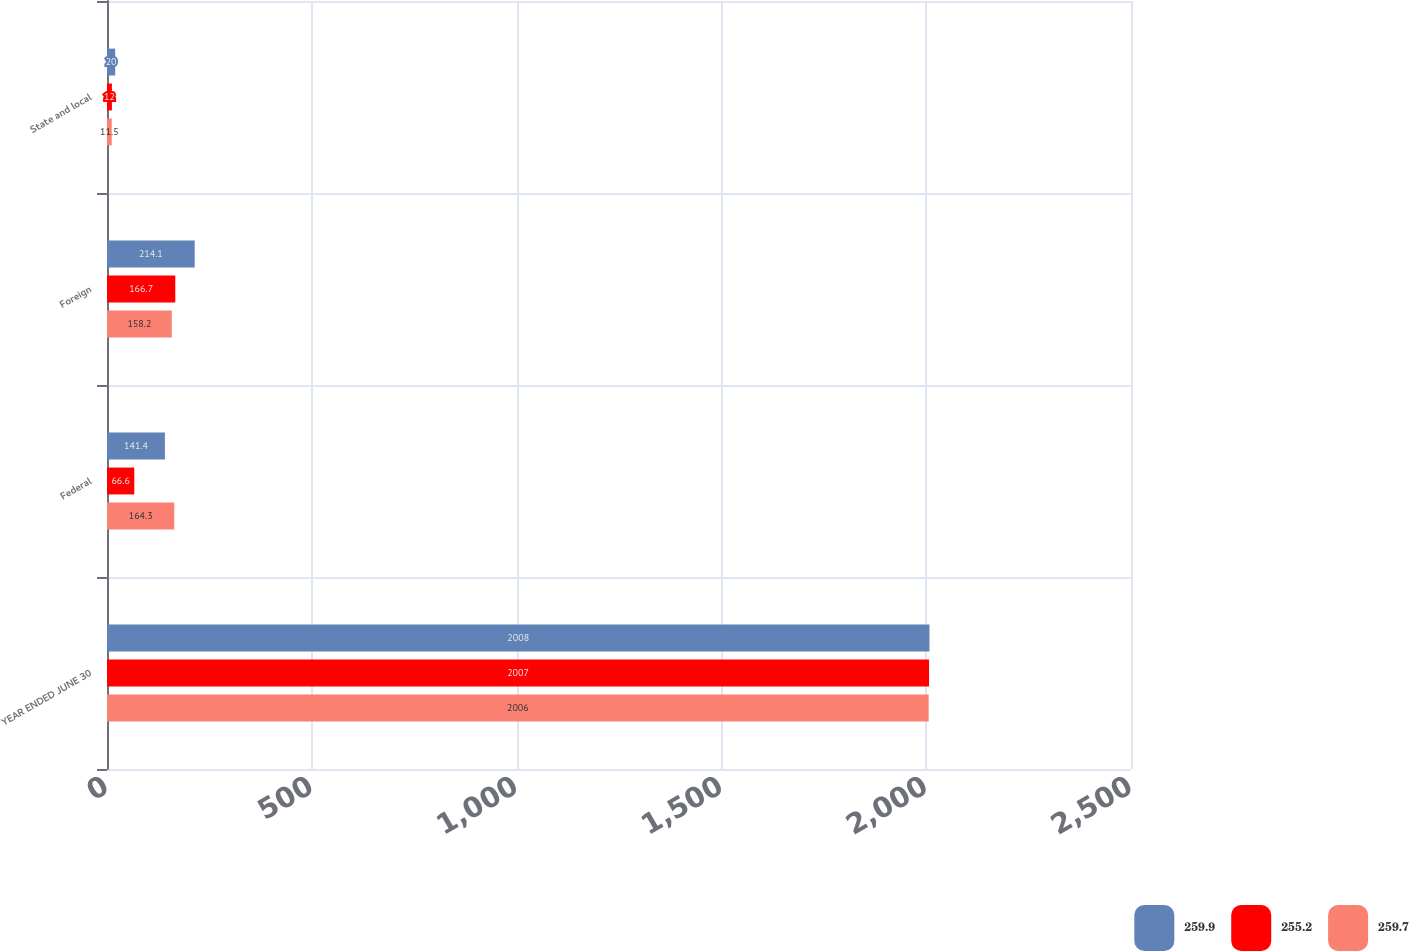<chart> <loc_0><loc_0><loc_500><loc_500><stacked_bar_chart><ecel><fcel>YEAR ENDED JUNE 30<fcel>Federal<fcel>Foreign<fcel>State and local<nl><fcel>259.9<fcel>2008<fcel>141.4<fcel>214.1<fcel>20<nl><fcel>255.2<fcel>2007<fcel>66.6<fcel>166.7<fcel>12<nl><fcel>259.7<fcel>2006<fcel>164.3<fcel>158.2<fcel>11.5<nl></chart> 